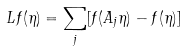<formula> <loc_0><loc_0><loc_500><loc_500>L f ( \eta ) = \sum _ { j } [ f ( A _ { j } \eta ) - f ( \eta ) ]</formula> 